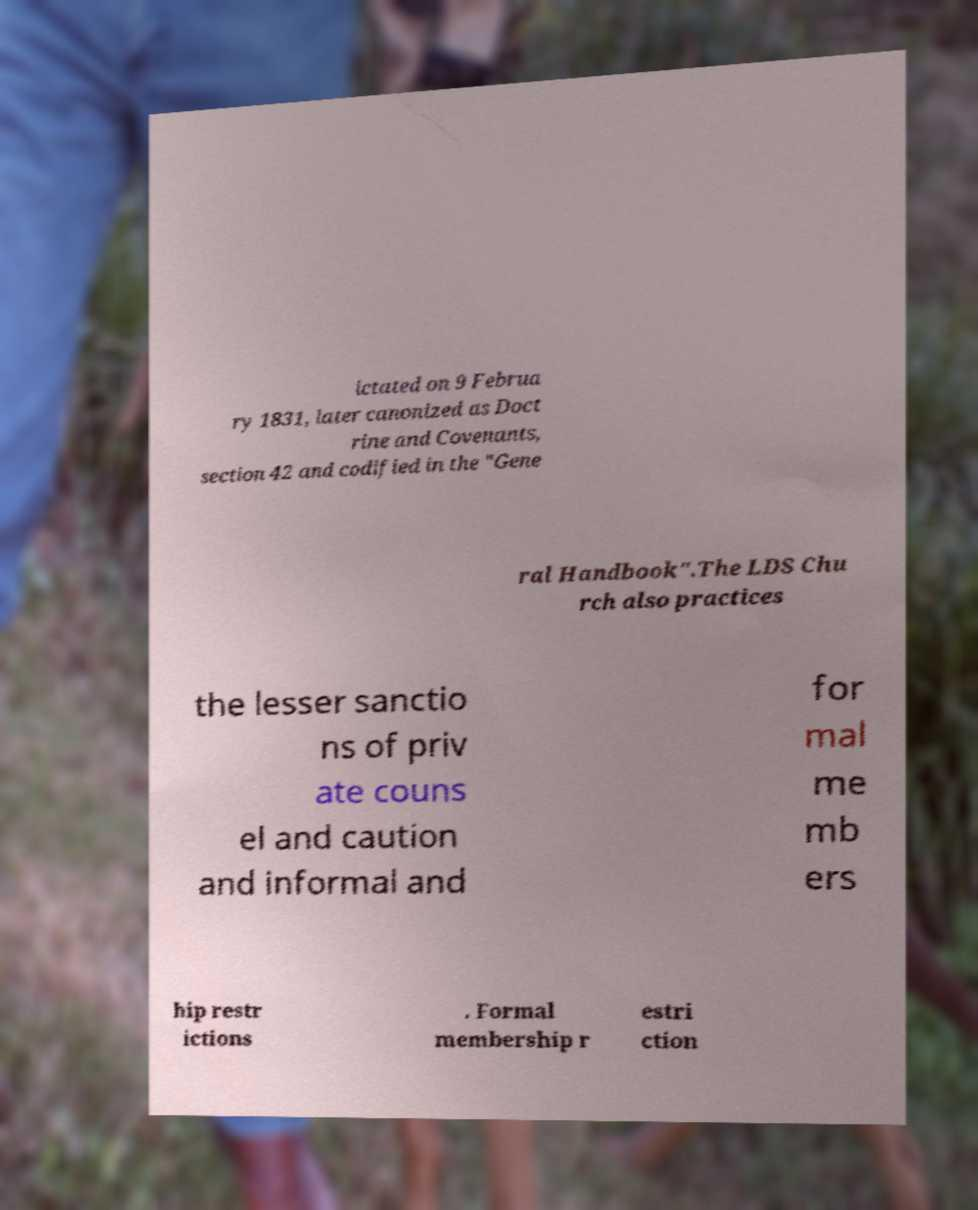Can you read and provide the text displayed in the image?This photo seems to have some interesting text. Can you extract and type it out for me? ictated on 9 Februa ry 1831, later canonized as Doct rine and Covenants, section 42 and codified in the "Gene ral Handbook".The LDS Chu rch also practices the lesser sanctio ns of priv ate couns el and caution and informal and for mal me mb ers hip restr ictions . Formal membership r estri ction 